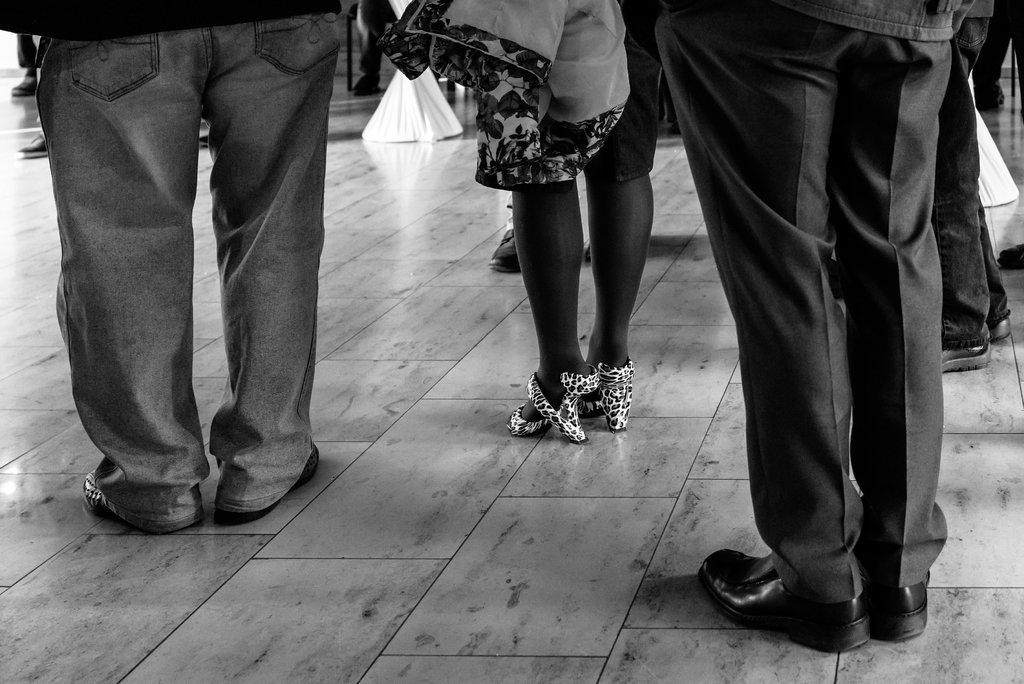What is happening in the image? There are people standing in the image. Can you describe any specific individuals in the image? One of the people is a woman. What is the color scheme of the image? The image is black and white. What type of watch is the woman wearing in the image? There is no watch visible in the image. What kind of fruit is being served for breakfast in the image? There is no breakfast or fruit present in the image. 